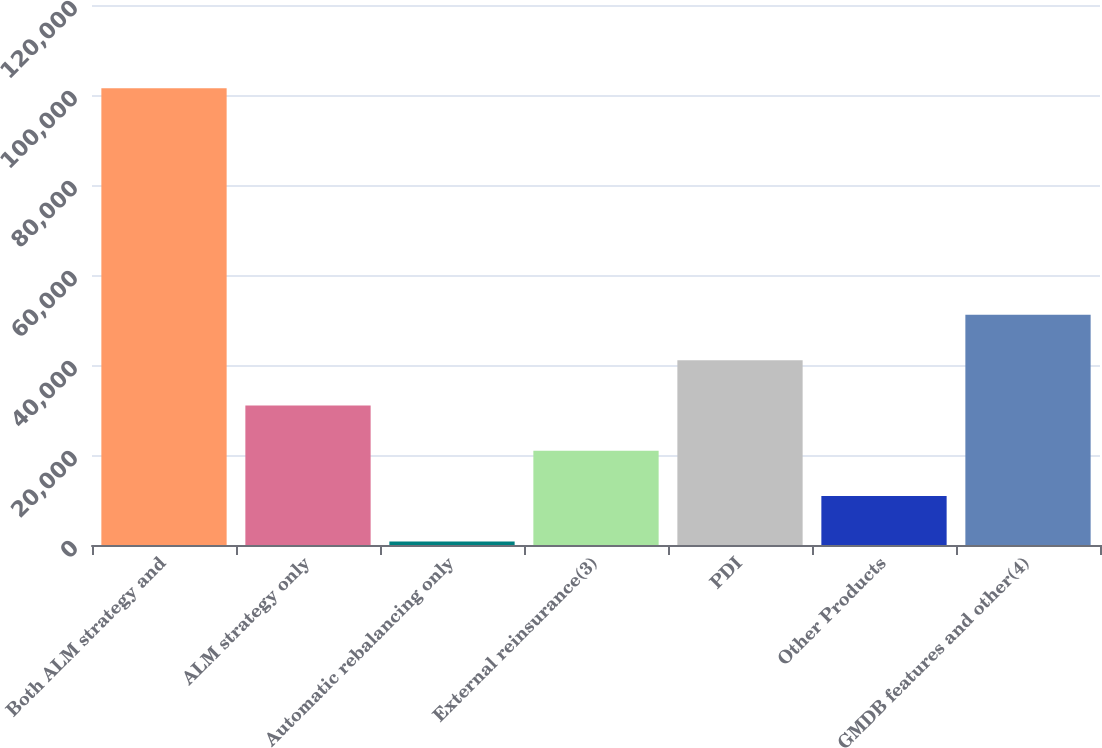<chart> <loc_0><loc_0><loc_500><loc_500><bar_chart><fcel>Both ALM strategy and<fcel>ALM strategy only<fcel>Automatic rebalancing only<fcel>External reinsurance(3)<fcel>PDI<fcel>Other Products<fcel>GMDB features and other(4)<nl><fcel>101496<fcel>31011.6<fcel>804<fcel>20942.4<fcel>41080.8<fcel>10873.2<fcel>51150<nl></chart> 